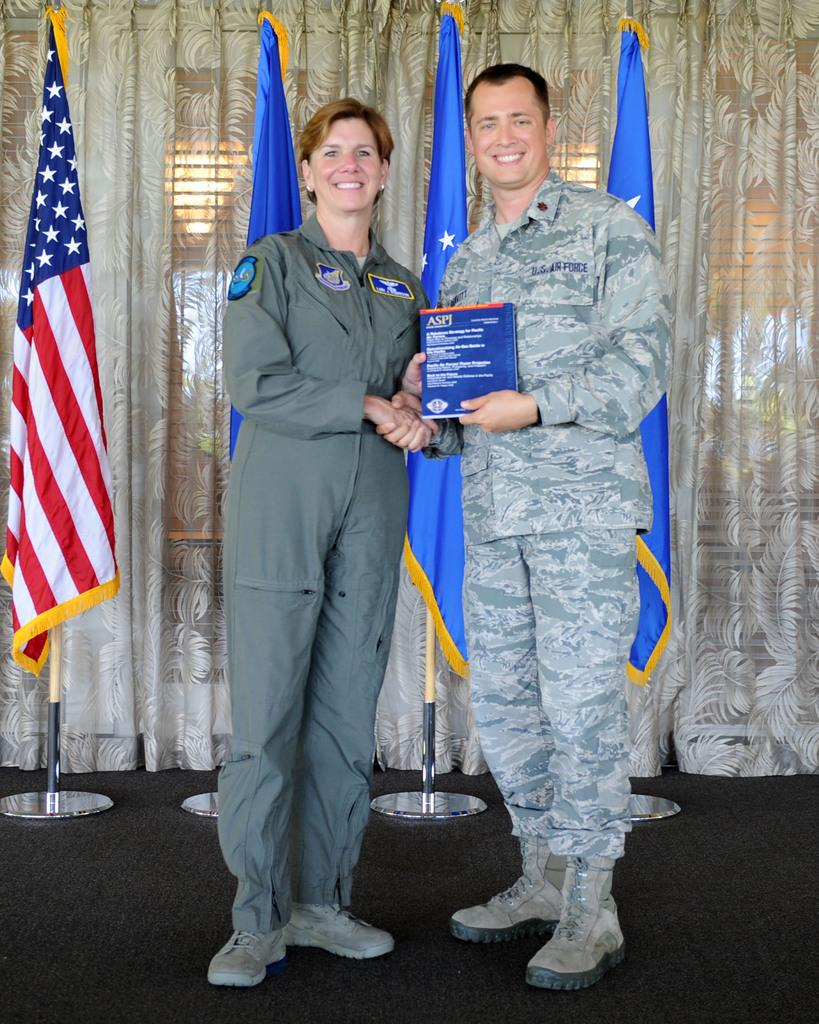Who is present in the image? There is a man and a woman in the image. What are the man and woman doing in the image? The man and woman are holding a book in the image. What can be seen in the background of the image? There are flags and curtains in the background of the image. What type of spark can be seen coming from the woman's hand in the image? There is no spark present in the image; the woman is holding a book with the man. 